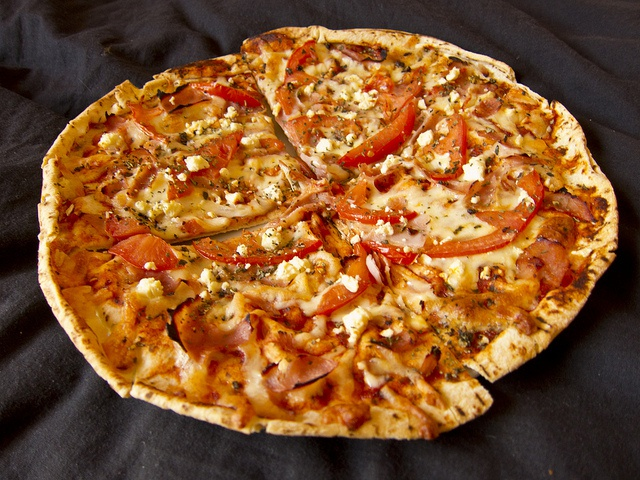Describe the objects in this image and their specific colors. I can see pizza in black, red, and tan tones, pizza in black, red, maroon, orange, and tan tones, and pizza in black, red, maroon, tan, and orange tones in this image. 